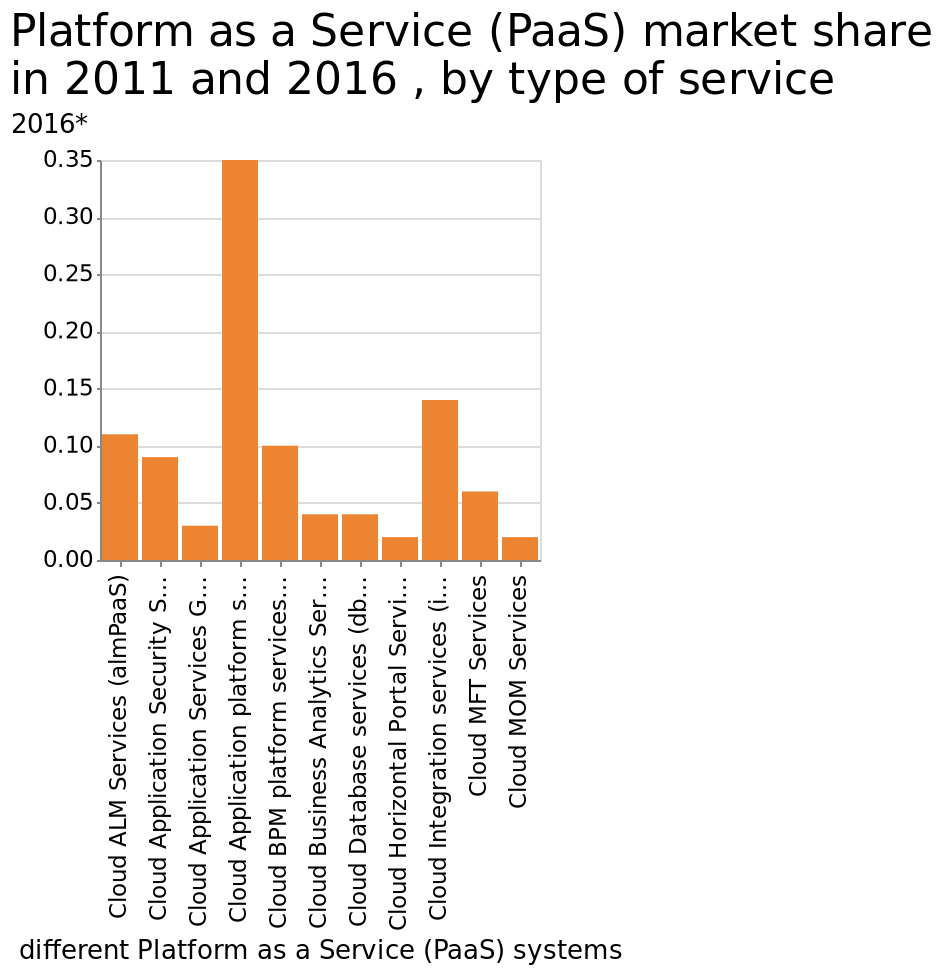<image>
Describe the following image in detail This is a bar graph named Platform as a Service (PaaS) market share in 2011 and 2016 , by type of service. The x-axis shows different Platform as a Service (PaaS) systems using categorical scale starting with Cloud ALM Services (almPaaS) and ending with Cloud MOM Services while the y-axis measures 2016* using scale from 0.00 to 0.35. What had the highest market share in the market? The cloud application platform had the highest market share. 